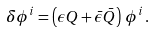<formula> <loc_0><loc_0><loc_500><loc_500>\delta \phi ^ { i } = \left ( \epsilon Q + \bar { \epsilon } \bar { Q } \right ) \, \phi ^ { i } \, .</formula> 